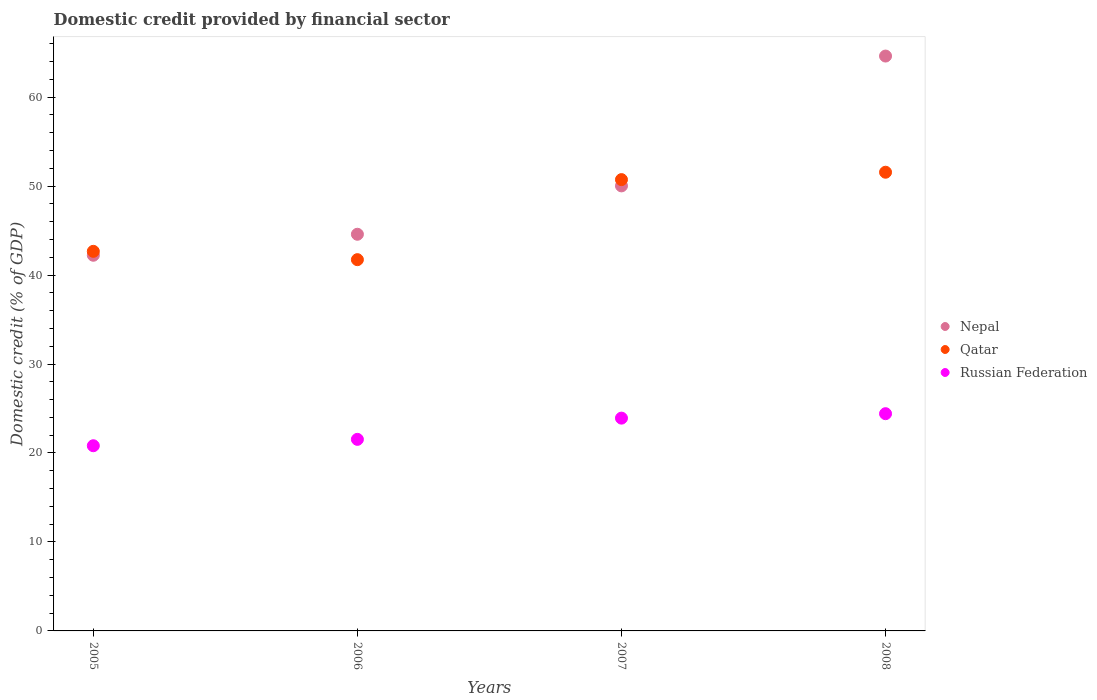How many different coloured dotlines are there?
Give a very brief answer. 3. Is the number of dotlines equal to the number of legend labels?
Offer a terse response. Yes. What is the domestic credit in Russian Federation in 2008?
Keep it short and to the point. 24.42. Across all years, what is the maximum domestic credit in Russian Federation?
Your answer should be very brief. 24.42. Across all years, what is the minimum domestic credit in Russian Federation?
Your response must be concise. 20.81. In which year was the domestic credit in Nepal maximum?
Provide a succinct answer. 2008. What is the total domestic credit in Nepal in the graph?
Ensure brevity in your answer.  201.44. What is the difference between the domestic credit in Nepal in 2006 and that in 2008?
Keep it short and to the point. -20.03. What is the difference between the domestic credit in Nepal in 2006 and the domestic credit in Qatar in 2005?
Your answer should be compact. 1.92. What is the average domestic credit in Qatar per year?
Offer a very short reply. 46.67. In the year 2005, what is the difference between the domestic credit in Nepal and domestic credit in Qatar?
Ensure brevity in your answer.  -0.44. What is the ratio of the domestic credit in Nepal in 2007 to that in 2008?
Provide a succinct answer. 0.77. Is the difference between the domestic credit in Nepal in 2006 and 2008 greater than the difference between the domestic credit in Qatar in 2006 and 2008?
Your answer should be compact. No. What is the difference between the highest and the second highest domestic credit in Russian Federation?
Provide a short and direct response. 0.5. What is the difference between the highest and the lowest domestic credit in Nepal?
Offer a terse response. 22.39. In how many years, is the domestic credit in Nepal greater than the average domestic credit in Nepal taken over all years?
Your response must be concise. 1. Is the domestic credit in Russian Federation strictly greater than the domestic credit in Qatar over the years?
Your answer should be very brief. No. Is the domestic credit in Qatar strictly less than the domestic credit in Russian Federation over the years?
Provide a short and direct response. No. How many dotlines are there?
Give a very brief answer. 3. What is the difference between two consecutive major ticks on the Y-axis?
Your answer should be very brief. 10. Are the values on the major ticks of Y-axis written in scientific E-notation?
Make the answer very short. No. Where does the legend appear in the graph?
Offer a very short reply. Center right. What is the title of the graph?
Provide a succinct answer. Domestic credit provided by financial sector. What is the label or title of the Y-axis?
Provide a succinct answer. Domestic credit (% of GDP). What is the Domestic credit (% of GDP) of Nepal in 2005?
Provide a succinct answer. 42.22. What is the Domestic credit (% of GDP) of Qatar in 2005?
Your response must be concise. 42.66. What is the Domestic credit (% of GDP) in Russian Federation in 2005?
Offer a terse response. 20.81. What is the Domestic credit (% of GDP) of Nepal in 2006?
Your answer should be compact. 44.58. What is the Domestic credit (% of GDP) of Qatar in 2006?
Give a very brief answer. 41.73. What is the Domestic credit (% of GDP) of Russian Federation in 2006?
Provide a short and direct response. 21.53. What is the Domestic credit (% of GDP) of Nepal in 2007?
Offer a terse response. 50.02. What is the Domestic credit (% of GDP) of Qatar in 2007?
Your answer should be compact. 50.72. What is the Domestic credit (% of GDP) of Russian Federation in 2007?
Provide a short and direct response. 23.92. What is the Domestic credit (% of GDP) of Nepal in 2008?
Ensure brevity in your answer.  64.61. What is the Domestic credit (% of GDP) of Qatar in 2008?
Your answer should be compact. 51.56. What is the Domestic credit (% of GDP) of Russian Federation in 2008?
Ensure brevity in your answer.  24.42. Across all years, what is the maximum Domestic credit (% of GDP) in Nepal?
Offer a terse response. 64.61. Across all years, what is the maximum Domestic credit (% of GDP) in Qatar?
Keep it short and to the point. 51.56. Across all years, what is the maximum Domestic credit (% of GDP) in Russian Federation?
Make the answer very short. 24.42. Across all years, what is the minimum Domestic credit (% of GDP) in Nepal?
Provide a short and direct response. 42.22. Across all years, what is the minimum Domestic credit (% of GDP) in Qatar?
Provide a short and direct response. 41.73. Across all years, what is the minimum Domestic credit (% of GDP) in Russian Federation?
Make the answer very short. 20.81. What is the total Domestic credit (% of GDP) in Nepal in the graph?
Keep it short and to the point. 201.44. What is the total Domestic credit (% of GDP) of Qatar in the graph?
Your answer should be compact. 186.67. What is the total Domestic credit (% of GDP) of Russian Federation in the graph?
Your response must be concise. 90.68. What is the difference between the Domestic credit (% of GDP) in Nepal in 2005 and that in 2006?
Provide a short and direct response. -2.36. What is the difference between the Domestic credit (% of GDP) in Qatar in 2005 and that in 2006?
Your answer should be compact. 0.94. What is the difference between the Domestic credit (% of GDP) of Russian Federation in 2005 and that in 2006?
Provide a succinct answer. -0.72. What is the difference between the Domestic credit (% of GDP) in Nepal in 2005 and that in 2007?
Give a very brief answer. -7.8. What is the difference between the Domestic credit (% of GDP) in Qatar in 2005 and that in 2007?
Keep it short and to the point. -8.06. What is the difference between the Domestic credit (% of GDP) in Russian Federation in 2005 and that in 2007?
Your response must be concise. -3.1. What is the difference between the Domestic credit (% of GDP) of Nepal in 2005 and that in 2008?
Your answer should be compact. -22.39. What is the difference between the Domestic credit (% of GDP) of Qatar in 2005 and that in 2008?
Keep it short and to the point. -8.89. What is the difference between the Domestic credit (% of GDP) of Russian Federation in 2005 and that in 2008?
Offer a terse response. -3.6. What is the difference between the Domestic credit (% of GDP) of Nepal in 2006 and that in 2007?
Your answer should be compact. -5.44. What is the difference between the Domestic credit (% of GDP) of Qatar in 2006 and that in 2007?
Your response must be concise. -9. What is the difference between the Domestic credit (% of GDP) of Russian Federation in 2006 and that in 2007?
Ensure brevity in your answer.  -2.39. What is the difference between the Domestic credit (% of GDP) of Nepal in 2006 and that in 2008?
Make the answer very short. -20.03. What is the difference between the Domestic credit (% of GDP) of Qatar in 2006 and that in 2008?
Give a very brief answer. -9.83. What is the difference between the Domestic credit (% of GDP) in Russian Federation in 2006 and that in 2008?
Give a very brief answer. -2.89. What is the difference between the Domestic credit (% of GDP) in Nepal in 2007 and that in 2008?
Offer a terse response. -14.59. What is the difference between the Domestic credit (% of GDP) of Qatar in 2007 and that in 2008?
Your answer should be compact. -0.83. What is the difference between the Domestic credit (% of GDP) in Russian Federation in 2007 and that in 2008?
Your answer should be very brief. -0.5. What is the difference between the Domestic credit (% of GDP) in Nepal in 2005 and the Domestic credit (% of GDP) in Qatar in 2006?
Offer a very short reply. 0.5. What is the difference between the Domestic credit (% of GDP) in Nepal in 2005 and the Domestic credit (% of GDP) in Russian Federation in 2006?
Provide a short and direct response. 20.69. What is the difference between the Domestic credit (% of GDP) in Qatar in 2005 and the Domestic credit (% of GDP) in Russian Federation in 2006?
Keep it short and to the point. 21.13. What is the difference between the Domestic credit (% of GDP) in Nepal in 2005 and the Domestic credit (% of GDP) in Russian Federation in 2007?
Your response must be concise. 18.31. What is the difference between the Domestic credit (% of GDP) of Qatar in 2005 and the Domestic credit (% of GDP) of Russian Federation in 2007?
Your response must be concise. 18.75. What is the difference between the Domestic credit (% of GDP) of Nepal in 2005 and the Domestic credit (% of GDP) of Qatar in 2008?
Your response must be concise. -9.33. What is the difference between the Domestic credit (% of GDP) of Nepal in 2005 and the Domestic credit (% of GDP) of Russian Federation in 2008?
Your answer should be compact. 17.81. What is the difference between the Domestic credit (% of GDP) of Qatar in 2005 and the Domestic credit (% of GDP) of Russian Federation in 2008?
Make the answer very short. 18.25. What is the difference between the Domestic credit (% of GDP) of Nepal in 2006 and the Domestic credit (% of GDP) of Qatar in 2007?
Offer a very short reply. -6.14. What is the difference between the Domestic credit (% of GDP) of Nepal in 2006 and the Domestic credit (% of GDP) of Russian Federation in 2007?
Your answer should be compact. 20.67. What is the difference between the Domestic credit (% of GDP) of Qatar in 2006 and the Domestic credit (% of GDP) of Russian Federation in 2007?
Ensure brevity in your answer.  17.81. What is the difference between the Domestic credit (% of GDP) of Nepal in 2006 and the Domestic credit (% of GDP) of Qatar in 2008?
Keep it short and to the point. -6.97. What is the difference between the Domestic credit (% of GDP) in Nepal in 2006 and the Domestic credit (% of GDP) in Russian Federation in 2008?
Provide a short and direct response. 20.17. What is the difference between the Domestic credit (% of GDP) in Qatar in 2006 and the Domestic credit (% of GDP) in Russian Federation in 2008?
Keep it short and to the point. 17.31. What is the difference between the Domestic credit (% of GDP) of Nepal in 2007 and the Domestic credit (% of GDP) of Qatar in 2008?
Make the answer very short. -1.53. What is the difference between the Domestic credit (% of GDP) in Nepal in 2007 and the Domestic credit (% of GDP) in Russian Federation in 2008?
Provide a succinct answer. 25.6. What is the difference between the Domestic credit (% of GDP) in Qatar in 2007 and the Domestic credit (% of GDP) in Russian Federation in 2008?
Offer a very short reply. 26.31. What is the average Domestic credit (% of GDP) in Nepal per year?
Your response must be concise. 50.36. What is the average Domestic credit (% of GDP) of Qatar per year?
Offer a terse response. 46.67. What is the average Domestic credit (% of GDP) in Russian Federation per year?
Ensure brevity in your answer.  22.67. In the year 2005, what is the difference between the Domestic credit (% of GDP) of Nepal and Domestic credit (% of GDP) of Qatar?
Keep it short and to the point. -0.44. In the year 2005, what is the difference between the Domestic credit (% of GDP) in Nepal and Domestic credit (% of GDP) in Russian Federation?
Ensure brevity in your answer.  21.41. In the year 2005, what is the difference between the Domestic credit (% of GDP) in Qatar and Domestic credit (% of GDP) in Russian Federation?
Provide a succinct answer. 21.85. In the year 2006, what is the difference between the Domestic credit (% of GDP) in Nepal and Domestic credit (% of GDP) in Qatar?
Your response must be concise. 2.86. In the year 2006, what is the difference between the Domestic credit (% of GDP) of Nepal and Domestic credit (% of GDP) of Russian Federation?
Provide a short and direct response. 23.05. In the year 2006, what is the difference between the Domestic credit (% of GDP) in Qatar and Domestic credit (% of GDP) in Russian Federation?
Provide a short and direct response. 20.2. In the year 2007, what is the difference between the Domestic credit (% of GDP) of Nepal and Domestic credit (% of GDP) of Qatar?
Your response must be concise. -0.7. In the year 2007, what is the difference between the Domestic credit (% of GDP) of Nepal and Domestic credit (% of GDP) of Russian Federation?
Your answer should be compact. 26.1. In the year 2007, what is the difference between the Domestic credit (% of GDP) in Qatar and Domestic credit (% of GDP) in Russian Federation?
Your answer should be very brief. 26.81. In the year 2008, what is the difference between the Domestic credit (% of GDP) of Nepal and Domestic credit (% of GDP) of Qatar?
Give a very brief answer. 13.06. In the year 2008, what is the difference between the Domestic credit (% of GDP) in Nepal and Domestic credit (% of GDP) in Russian Federation?
Provide a succinct answer. 40.2. In the year 2008, what is the difference between the Domestic credit (% of GDP) of Qatar and Domestic credit (% of GDP) of Russian Federation?
Your response must be concise. 27.14. What is the ratio of the Domestic credit (% of GDP) in Nepal in 2005 to that in 2006?
Provide a short and direct response. 0.95. What is the ratio of the Domestic credit (% of GDP) of Qatar in 2005 to that in 2006?
Offer a very short reply. 1.02. What is the ratio of the Domestic credit (% of GDP) of Russian Federation in 2005 to that in 2006?
Offer a very short reply. 0.97. What is the ratio of the Domestic credit (% of GDP) in Nepal in 2005 to that in 2007?
Give a very brief answer. 0.84. What is the ratio of the Domestic credit (% of GDP) of Qatar in 2005 to that in 2007?
Make the answer very short. 0.84. What is the ratio of the Domestic credit (% of GDP) of Russian Federation in 2005 to that in 2007?
Make the answer very short. 0.87. What is the ratio of the Domestic credit (% of GDP) in Nepal in 2005 to that in 2008?
Make the answer very short. 0.65. What is the ratio of the Domestic credit (% of GDP) of Qatar in 2005 to that in 2008?
Offer a terse response. 0.83. What is the ratio of the Domestic credit (% of GDP) in Russian Federation in 2005 to that in 2008?
Provide a short and direct response. 0.85. What is the ratio of the Domestic credit (% of GDP) of Nepal in 2006 to that in 2007?
Keep it short and to the point. 0.89. What is the ratio of the Domestic credit (% of GDP) in Qatar in 2006 to that in 2007?
Your answer should be very brief. 0.82. What is the ratio of the Domestic credit (% of GDP) of Russian Federation in 2006 to that in 2007?
Your answer should be very brief. 0.9. What is the ratio of the Domestic credit (% of GDP) in Nepal in 2006 to that in 2008?
Your response must be concise. 0.69. What is the ratio of the Domestic credit (% of GDP) of Qatar in 2006 to that in 2008?
Make the answer very short. 0.81. What is the ratio of the Domestic credit (% of GDP) of Russian Federation in 2006 to that in 2008?
Your answer should be very brief. 0.88. What is the ratio of the Domestic credit (% of GDP) of Nepal in 2007 to that in 2008?
Make the answer very short. 0.77. What is the ratio of the Domestic credit (% of GDP) of Qatar in 2007 to that in 2008?
Keep it short and to the point. 0.98. What is the ratio of the Domestic credit (% of GDP) in Russian Federation in 2007 to that in 2008?
Your answer should be compact. 0.98. What is the difference between the highest and the second highest Domestic credit (% of GDP) in Nepal?
Your answer should be very brief. 14.59. What is the difference between the highest and the second highest Domestic credit (% of GDP) in Qatar?
Provide a short and direct response. 0.83. What is the difference between the highest and the second highest Domestic credit (% of GDP) in Russian Federation?
Offer a very short reply. 0.5. What is the difference between the highest and the lowest Domestic credit (% of GDP) in Nepal?
Provide a short and direct response. 22.39. What is the difference between the highest and the lowest Domestic credit (% of GDP) of Qatar?
Keep it short and to the point. 9.83. What is the difference between the highest and the lowest Domestic credit (% of GDP) of Russian Federation?
Offer a very short reply. 3.6. 